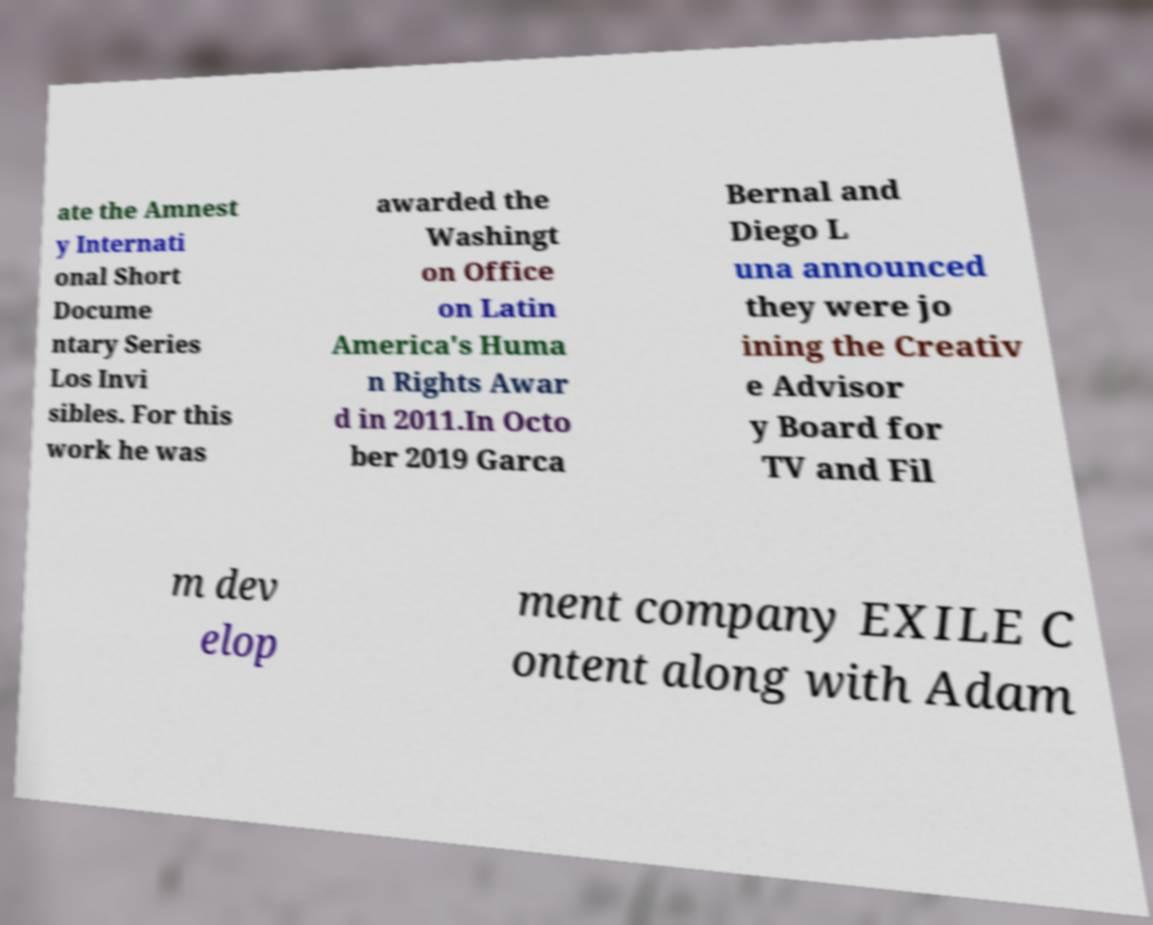Can you accurately transcribe the text from the provided image for me? ate the Amnest y Internati onal Short Docume ntary Series Los Invi sibles. For this work he was awarded the Washingt on Office on Latin America's Huma n Rights Awar d in 2011.In Octo ber 2019 Garca Bernal and Diego L una announced they were jo ining the Creativ e Advisor y Board for TV and Fil m dev elop ment company EXILE C ontent along with Adam 